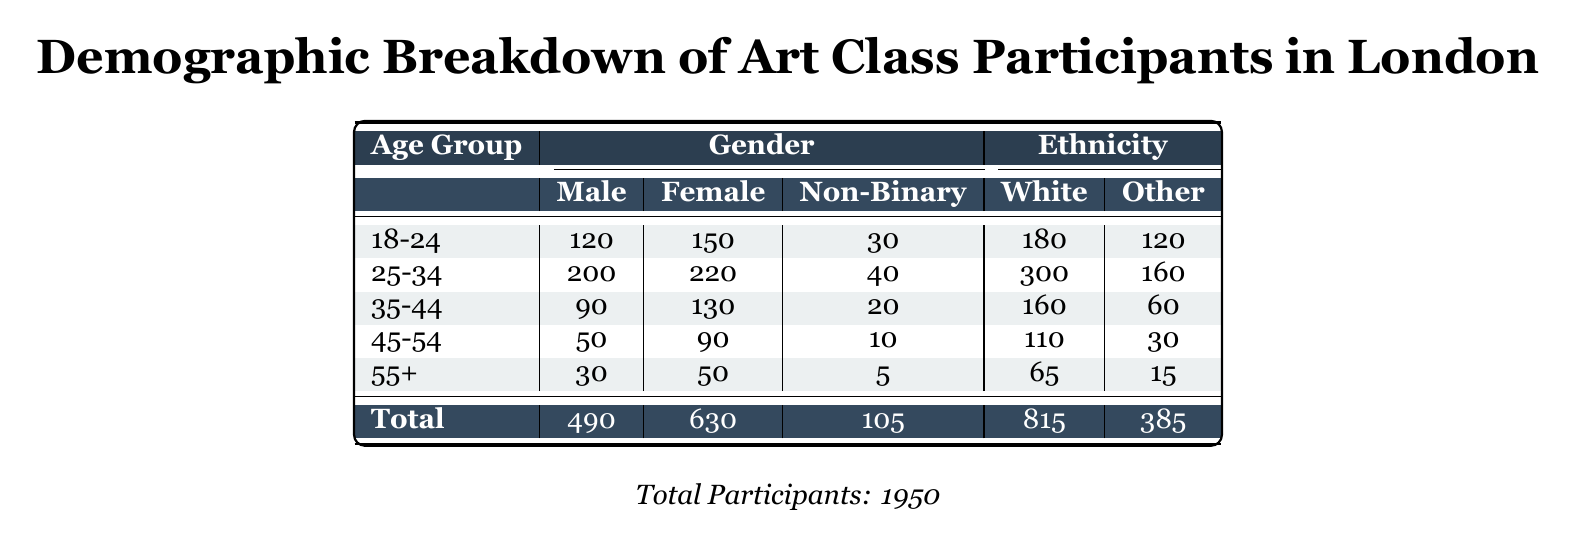What is the total number of male participants in the art classes? The table shows that the total number of male participants is provided in the last row under the Gender section, which is 490.
Answer: 490 What is the total number of non-binary participants? The total number of non-binary participants can be found in the last row under the Gender section, listed as 105.
Answer: 105 In the age group 25-34, how many more female participants are there compared to male participants? In the age group 25-34, there are 220 female participants and 200 male participants. The difference is 220 - 200 = 20.
Answer: 20 What percentage of the total participants are White? The total number of participants is 1950, and the number of White participants is 815. The percentage is calculated as (815 / 1950) * 100, which is approximately 41.77%.
Answer: 41.77% Is the number of Black participants greater than the number of Asian participants? The total number of Black participants is 155, and the Asian participants total 152. Since 155 is greater than 152, the statement is true.
Answer: Yes What is the total number of participants in the painting class? The total number of participants in the painting class is listed under Art Class Type as 800.
Answer: 800 In which age group is the highest number of female participants? According to the table, the age group 25-34 has the highest number of female participants with 220.
Answer: 25-34 What is the combined number of male participants in the age groups 18-24 and 35-44? The male participants in the 18-24 age group are 120 and in the 35-44 age group are 90. Combining these gives 120 + 90 = 210.
Answer: 210 What is the total number of Mixed ethnicity participants across all age groups? The total number of Mixed ethnicity participants is found by summing the values in each age group, which gives 30 + 30 + 10 + 5 + 3 = 78.
Answer: 78 Which gender category has the least number of participants overall? Looking at the total counts, Male has 490, Female has 630, and Non-Binary has 105. The Non-Binary category has the least participants.
Answer: Non-Binary 